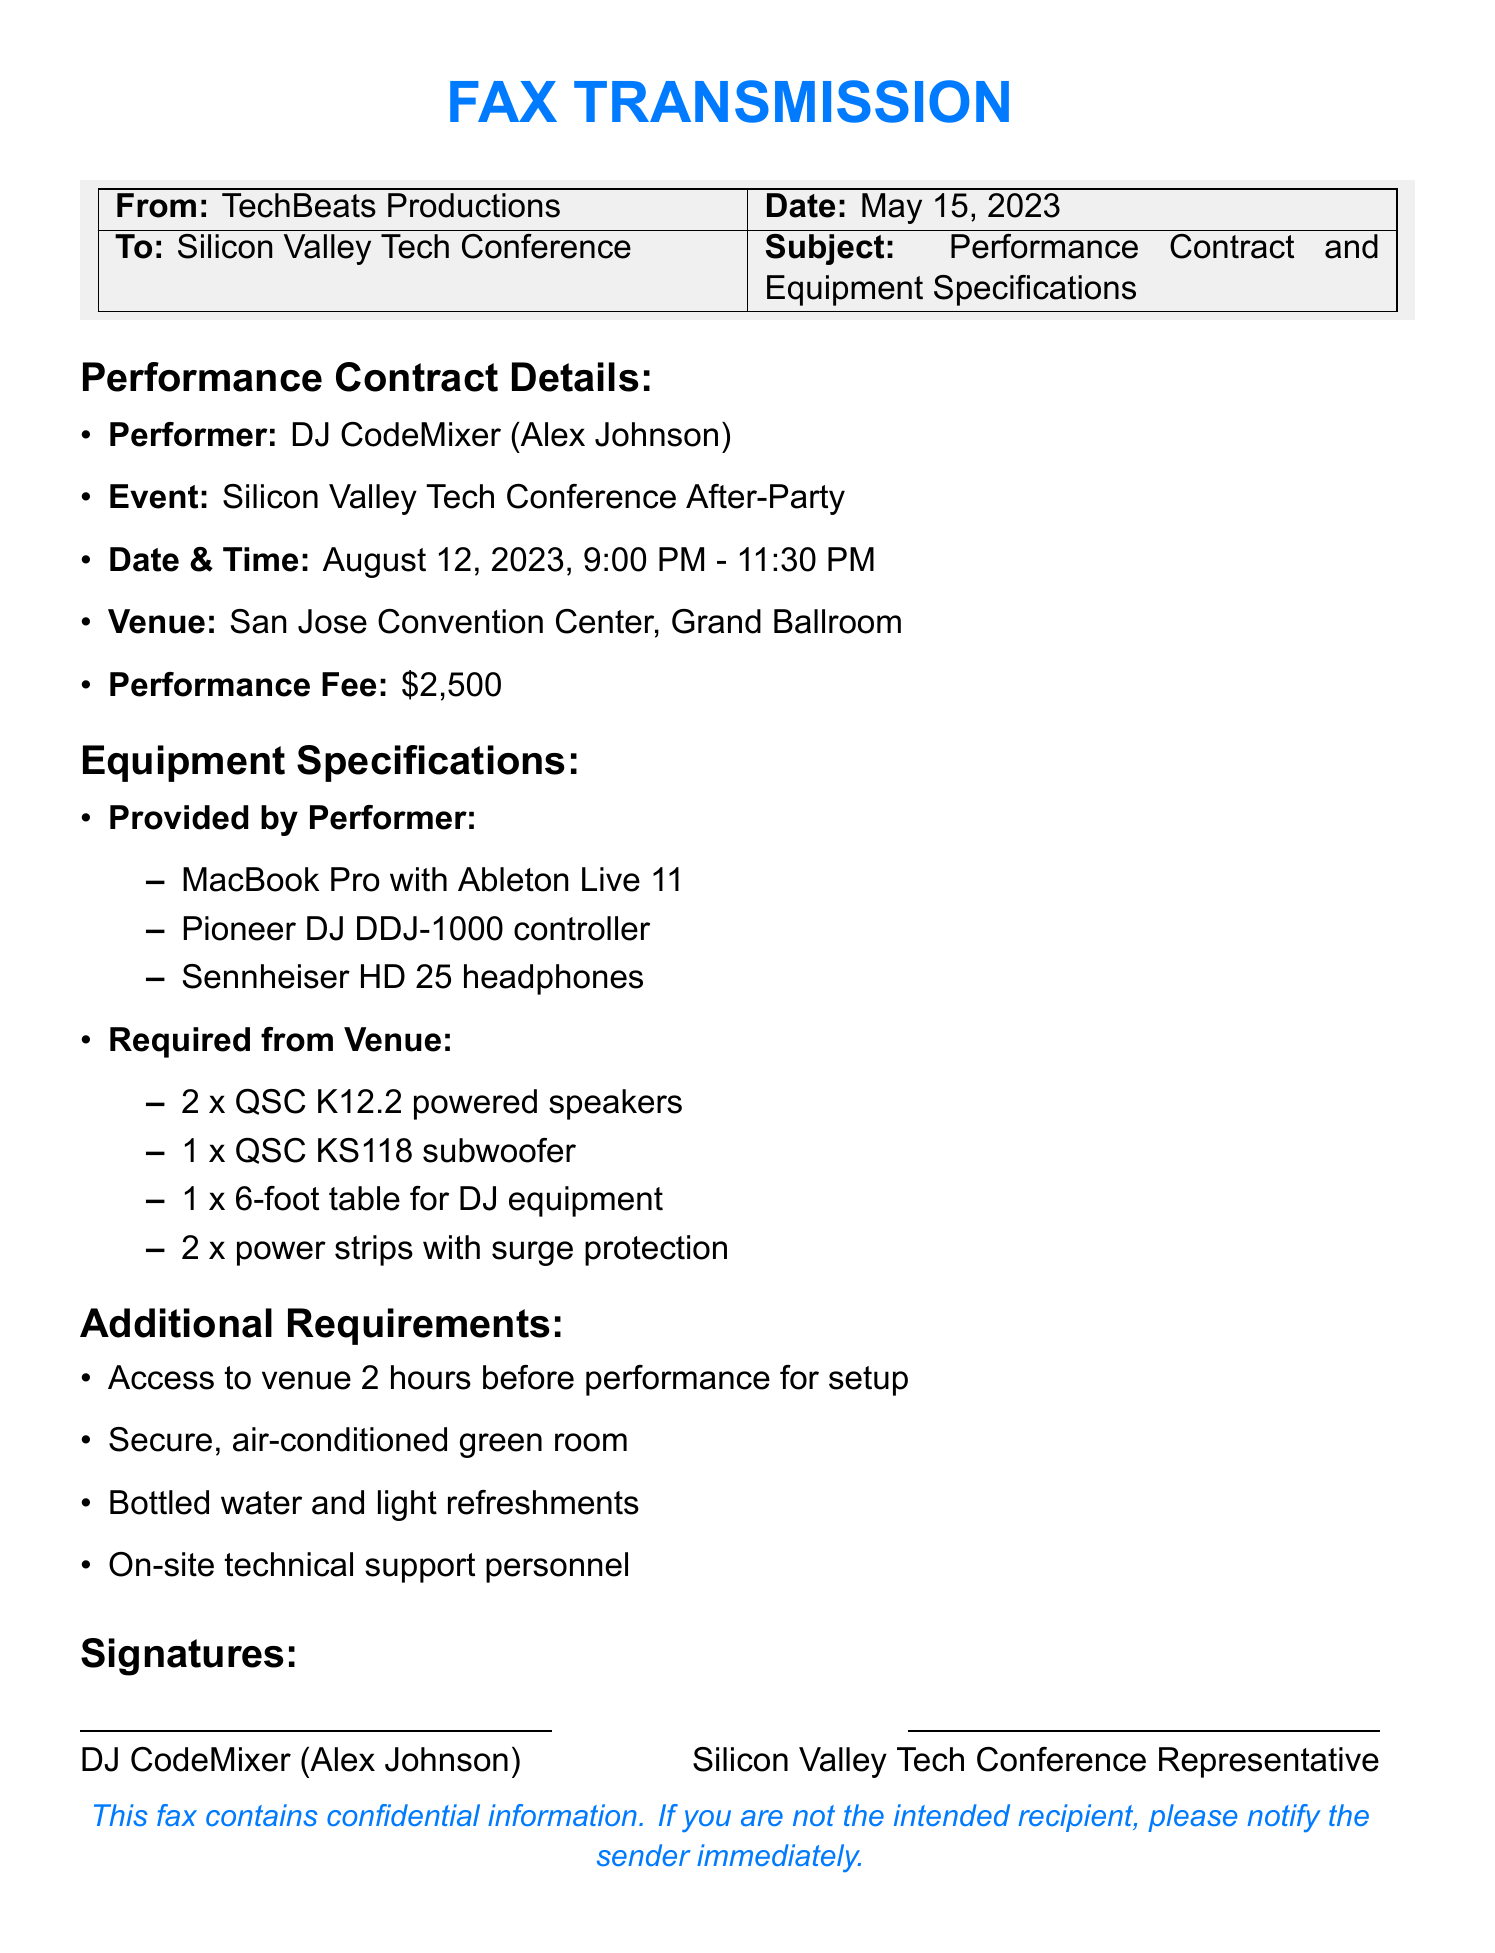What is the performer's name? The performer's name is explicitly stated in the document as DJ CodeMixer, which refers to Alex Johnson.
Answer: DJ CodeMixer (Alex Johnson) What is the performance fee? The performance fee is mentioned in the contract details as a specific amount.
Answer: $2,500 What time does the performance start? The document provides the start time of the performance clearly in the details.
Answer: 9:00 PM How many powered speakers are required from the venue? The document specifies the number of powered speakers needed, indicating a direct requirement.
Answer: 2 What is required for the DJ's equipment setup? The document lists items needed for the equipment setup as per the contract requirements.
Answer: 1 x 6-foot table for DJ equipment What type of headphones will the performer bring? The type of headphones that the performer is providing is directly stated in the equipment specifications.
Answer: Sennheiser HD 25 headphones How many hours prior to the performance can the performer access the venue? The document specifies access provisions for the performer to set up before the performance.
Answer: 2 hours What is included in the additional requirements for refreshments? The document contains specific mentions of items provided for the performer's needs.
Answer: Bottled water and light refreshments Who signed the contract for the organizers? The document states the representative who signs on behalf of the Silicon Valley Tech Conference.
Answer: Silicon Valley Tech Conference Representative 